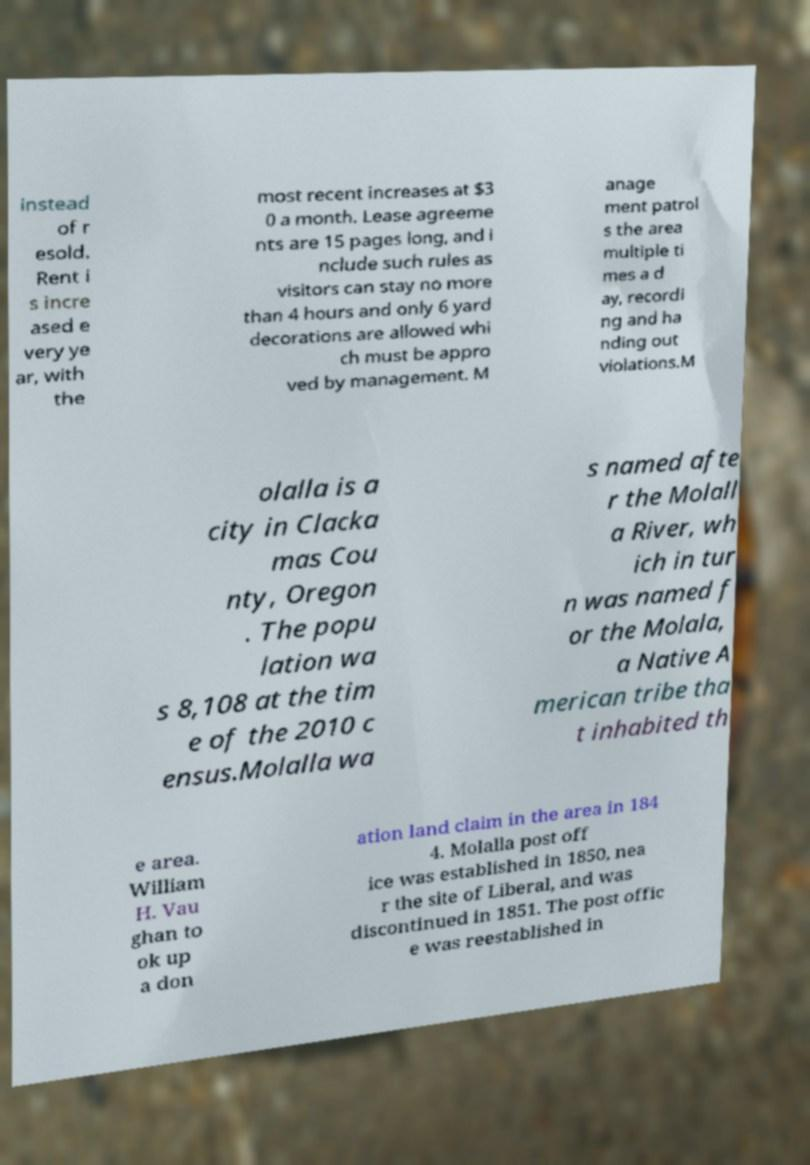Can you accurately transcribe the text from the provided image for me? instead of r esold. Rent i s incre ased e very ye ar, with the most recent increases at $3 0 a month. Lease agreeme nts are 15 pages long, and i nclude such rules as visitors can stay no more than 4 hours and only 6 yard decorations are allowed whi ch must be appro ved by management. M anage ment patrol s the area multiple ti mes a d ay, recordi ng and ha nding out violations.M olalla is a city in Clacka mas Cou nty, Oregon . The popu lation wa s 8,108 at the tim e of the 2010 c ensus.Molalla wa s named afte r the Molall a River, wh ich in tur n was named f or the Molala, a Native A merican tribe tha t inhabited th e area. William H. Vau ghan to ok up a don ation land claim in the area in 184 4. Molalla post off ice was established in 1850, nea r the site of Liberal, and was discontinued in 1851. The post offic e was reestablished in 